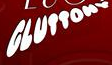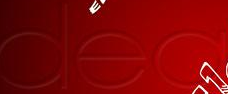Read the text content from these images in order, separated by a semicolon. GLUTTONV; dea 